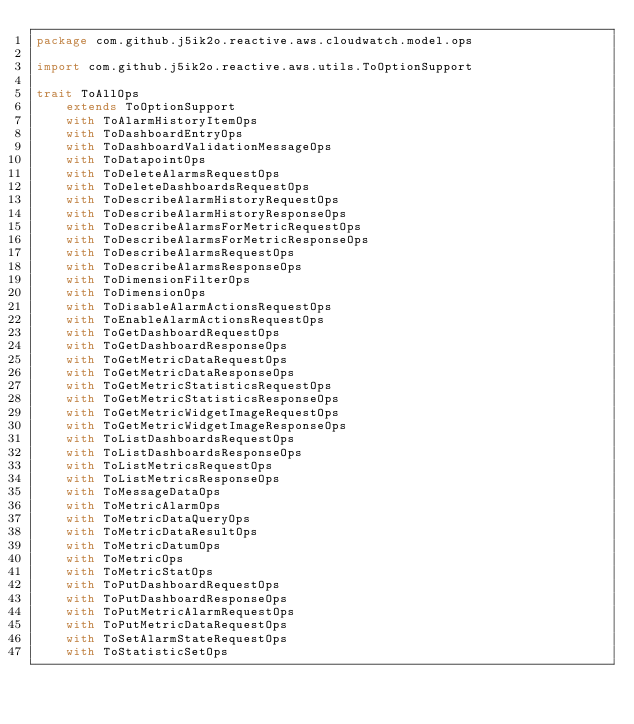<code> <loc_0><loc_0><loc_500><loc_500><_Scala_>package com.github.j5ik2o.reactive.aws.cloudwatch.model.ops

import com.github.j5ik2o.reactive.aws.utils.ToOptionSupport

trait ToAllOps
    extends ToOptionSupport
    with ToAlarmHistoryItemOps
    with ToDashboardEntryOps
    with ToDashboardValidationMessageOps
    with ToDatapointOps
    with ToDeleteAlarmsRequestOps
    with ToDeleteDashboardsRequestOps
    with ToDescribeAlarmHistoryRequestOps
    with ToDescribeAlarmHistoryResponseOps
    with ToDescribeAlarmsForMetricRequestOps
    with ToDescribeAlarmsForMetricResponseOps
    with ToDescribeAlarmsRequestOps
    with ToDescribeAlarmsResponseOps
    with ToDimensionFilterOps
    with ToDimensionOps
    with ToDisableAlarmActionsRequestOps
    with ToEnableAlarmActionsRequestOps
    with ToGetDashboardRequestOps
    with ToGetDashboardResponseOps
    with ToGetMetricDataRequestOps
    with ToGetMetricDataResponseOps
    with ToGetMetricStatisticsRequestOps
    with ToGetMetricStatisticsResponseOps
    with ToGetMetricWidgetImageRequestOps
    with ToGetMetricWidgetImageResponseOps
    with ToListDashboardsRequestOps
    with ToListDashboardsResponseOps
    with ToListMetricsRequestOps
    with ToListMetricsResponseOps
    with ToMessageDataOps
    with ToMetricAlarmOps
    with ToMetricDataQueryOps
    with ToMetricDataResultOps
    with ToMetricDatumOps
    with ToMetricOps
    with ToMetricStatOps
    with ToPutDashboardRequestOps
    with ToPutDashboardResponseOps
    with ToPutMetricAlarmRequestOps
    with ToPutMetricDataRequestOps
    with ToSetAlarmStateRequestOps
    with ToStatisticSetOps
</code> 